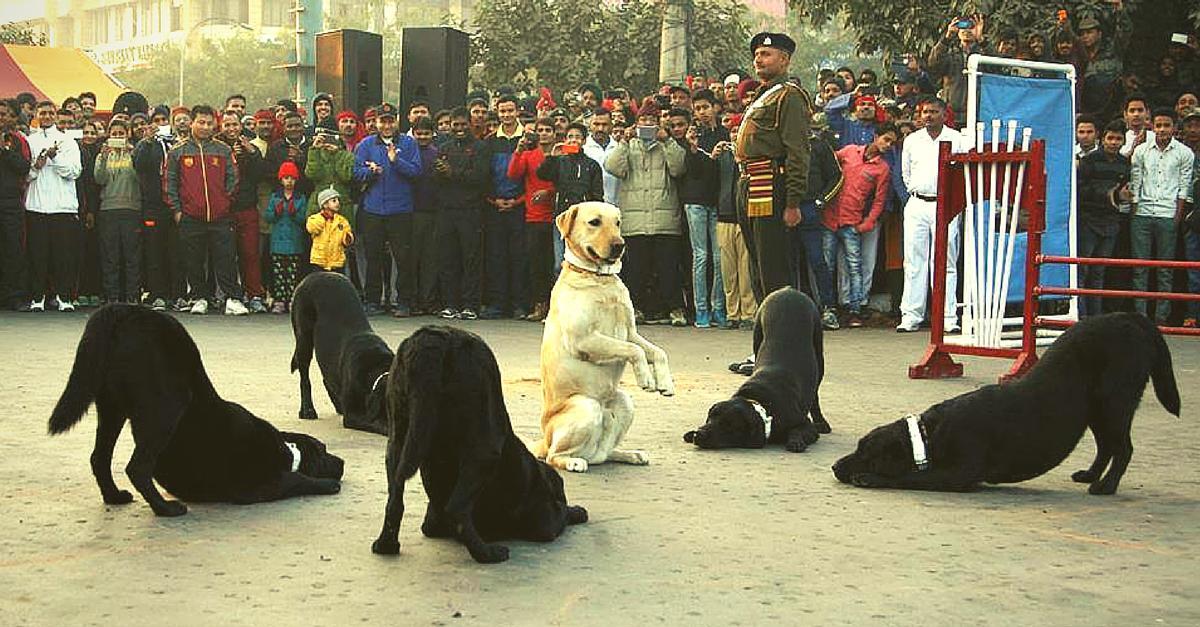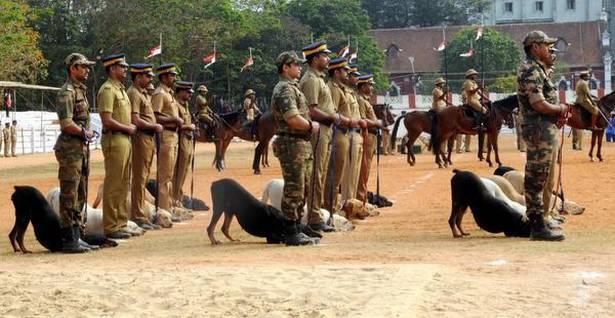The first image is the image on the left, the second image is the image on the right. Given the left and right images, does the statement "In one of the images, only one dog is present." hold true? Answer yes or no. No. The first image is the image on the left, the second image is the image on the right. Given the left and right images, does the statement "At least one dog is sitting." hold true? Answer yes or no. Yes. 